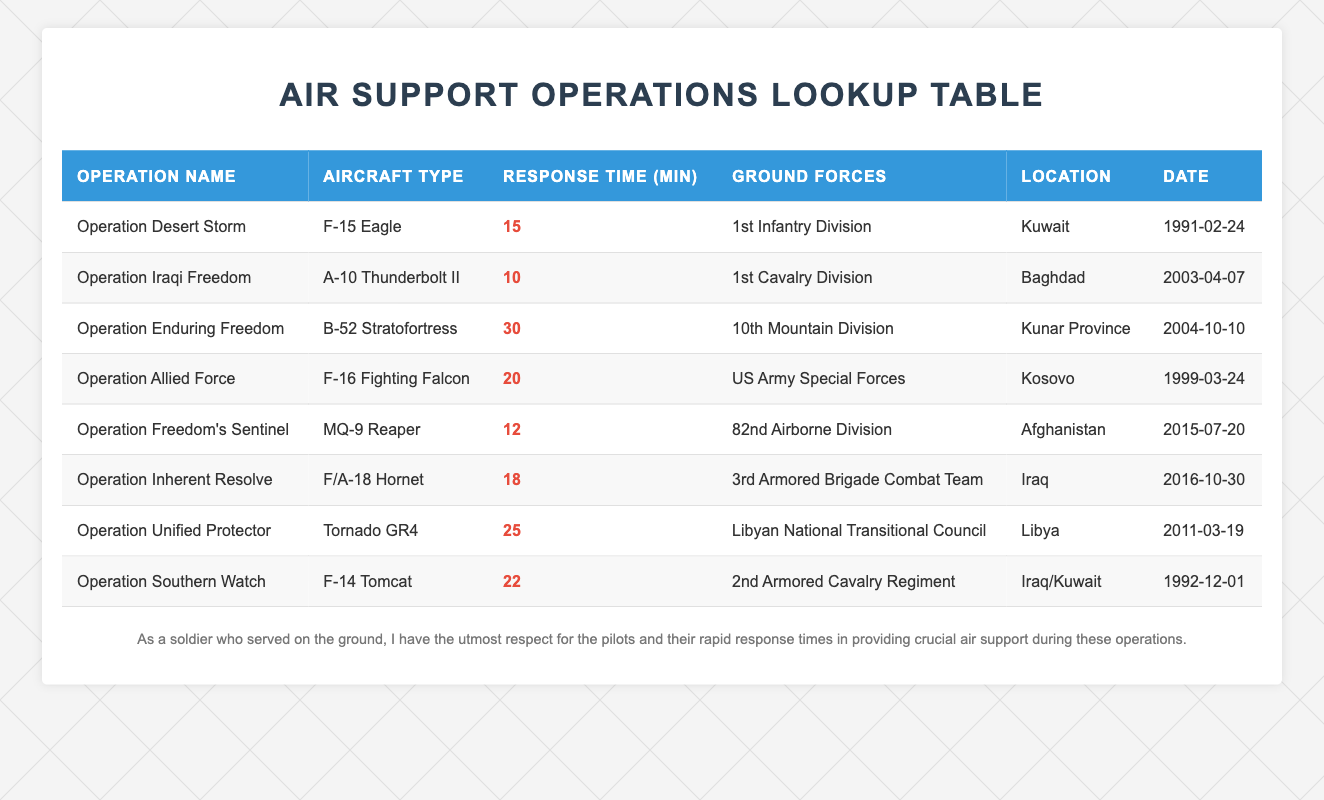What was the response time for Operation Iraqi Freedom? The response time for Operation Iraqi Freedom is found in the 'Response Time (min)' column for that specific operation, which lists 10 minutes.
Answer: 10 Which aircraft type had the longest response time? To find the longest response time, we examine the 'Response Time (min)' column across all operations and see that the B-52 Stratofortress for Operation Enduring Freedom has the highest at 30 minutes.
Answer: B-52 Stratofortress Did all operations provide air support to U.S. ground forces? By checking the 'Ground Forces' column, we confirm that all listed operations supported U.S. ground forces, hence the answer is yes.
Answer: Yes What is the average response time for all operations listed? To calculate the average, we sum the response times (15 + 10 + 30 + 20 + 12 + 18 + 25 + 22) = 142 minutes and divide by the number of operations (8). The average response time is 142/8 = 17.75 minutes.
Answer: 17.75 Which operation had the shortest response time, and what was it? By scanning the 'Response Time (min)' column, we find that Operation Iraqi Freedom had the shortest response time of 10 minutes.
Answer: Operation Iraqi Freedom, 10 minutes How many operations had a response time greater than 20 minutes? We review the 'Response Time (min)' column to count operations: Operation Enduring Freedom (30), Operation Unified Protector (25), and Operation Southern Watch (22), totaling three operations that exceed 20 minutes.
Answer: 3 In which location was Operation Freedom's Sentinel conducted? The 'Location' column identifies that Operation Freedom's Sentinel was conducted in Afghanistan.
Answer: Afghanistan Are there any operations that used the A-10 Thunderbolt II? By checking the 'Aircraft Type' column, we see that Operation Iraqi Freedom is the only operation that utilized the A-10 Thunderbolt II.
Answer: Yes 